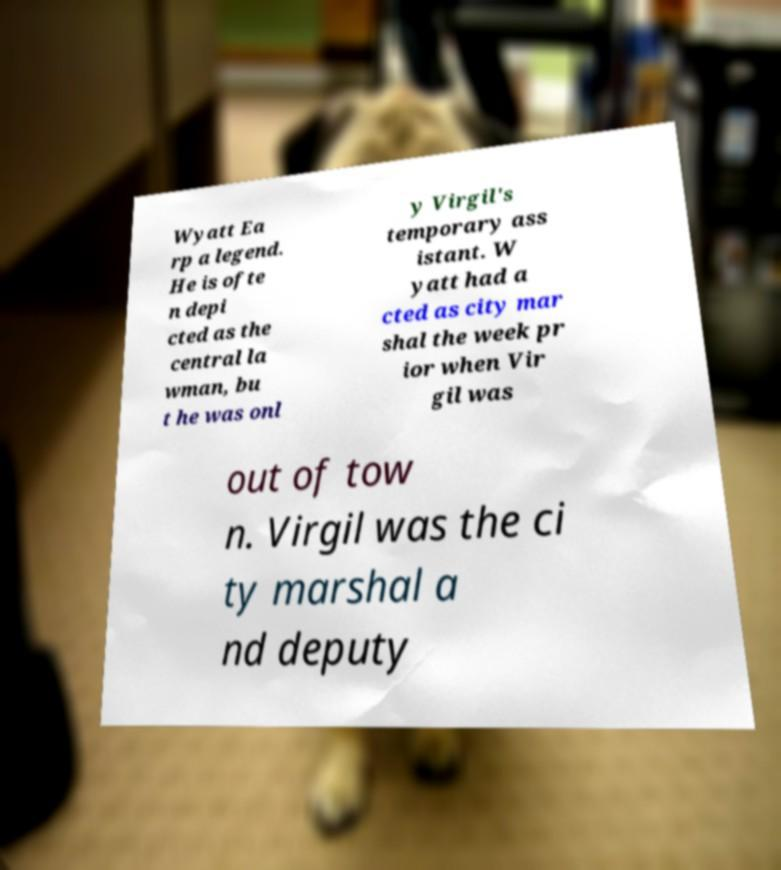There's text embedded in this image that I need extracted. Can you transcribe it verbatim? Wyatt Ea rp a legend. He is ofte n depi cted as the central la wman, bu t he was onl y Virgil's temporary ass istant. W yatt had a cted as city mar shal the week pr ior when Vir gil was out of tow n. Virgil was the ci ty marshal a nd deputy 